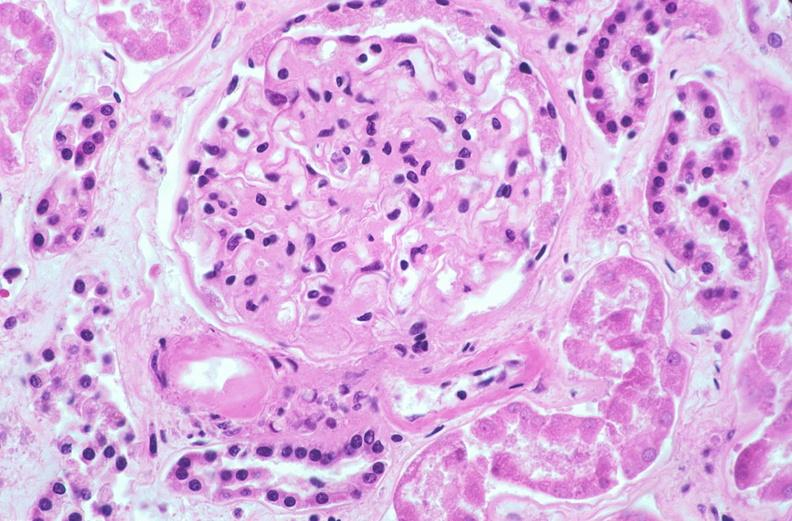where is this?
Answer the question using a single word or phrase. Urinary 